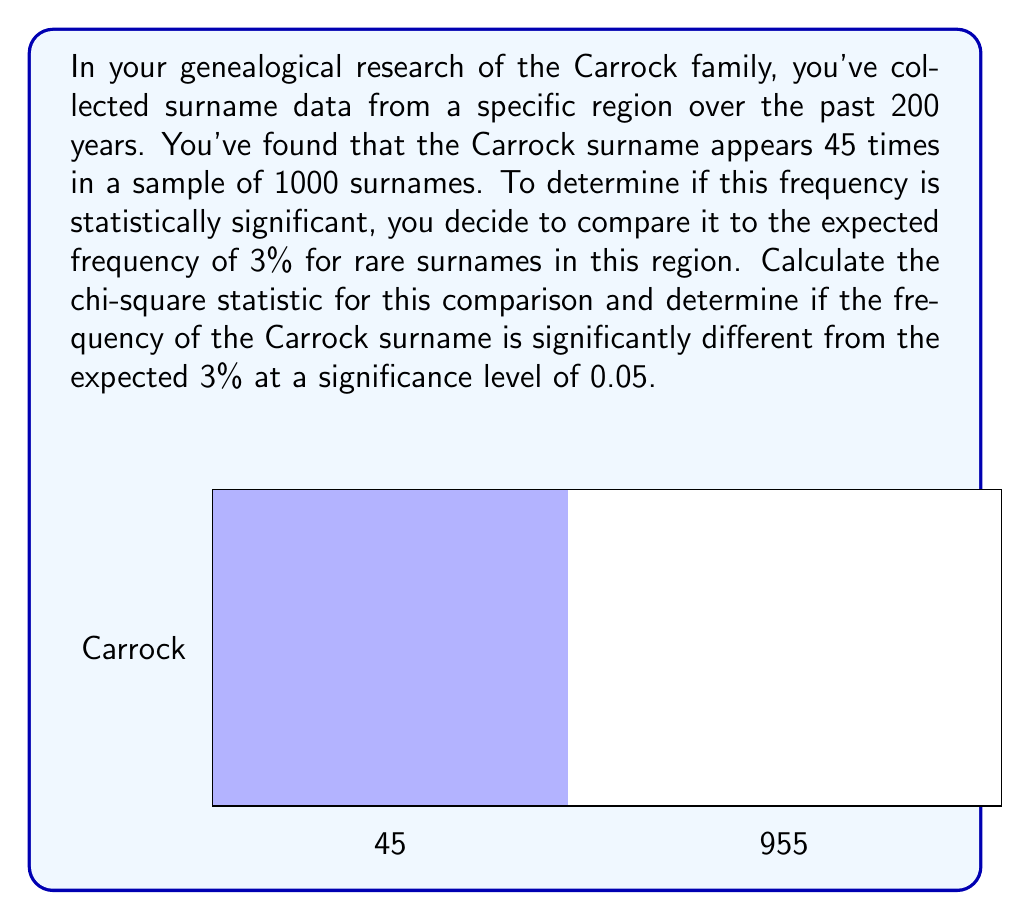Can you answer this question? To analyze the statistical significance of the Carrock surname frequency, we'll use the chi-square test for goodness of fit. Here's the step-by-step process:

1. Set up the null and alternative hypotheses:
   $H_0$: The frequency of the Carrock surname is not significantly different from 3%.
   $H_1$: The frequency of the Carrock surname is significantly different from 3%.

2. Calculate the expected frequency:
   Expected count = 1000 * 0.03 = 30

3. Calculate the chi-square statistic using the formula:
   $$\chi^2 = \sum\frac{(O_i - E_i)^2}{E_i}$$
   Where $O_i$ is the observed frequency and $E_i$ is the expected frequency.

   $$\chi^2 = \frac{(45 - 30)^2}{30} + \frac{(955 - 970)^2}{970}$$

4. Simplify the calculation:
   $$\chi^2 = \frac{225}{30} + \frac{225}{970} = 7.5 + 0.232 = 7.732$$

5. Determine the degrees of freedom (df):
   df = number of categories - 1 = 2 - 1 = 1

6. Find the critical value:
   For df = 1 and α = 0.05, the critical value is 3.841 (from chi-square distribution table)

7. Compare the calculated chi-square value to the critical value:
   7.732 > 3.841, so we reject the null hypothesis.

Therefore, the frequency of the Carrock surname (4.5%) is statistically significantly different from the expected 3% at the 0.05 significance level.
Answer: $\chi^2 = 7.732$, reject $H_0$ 